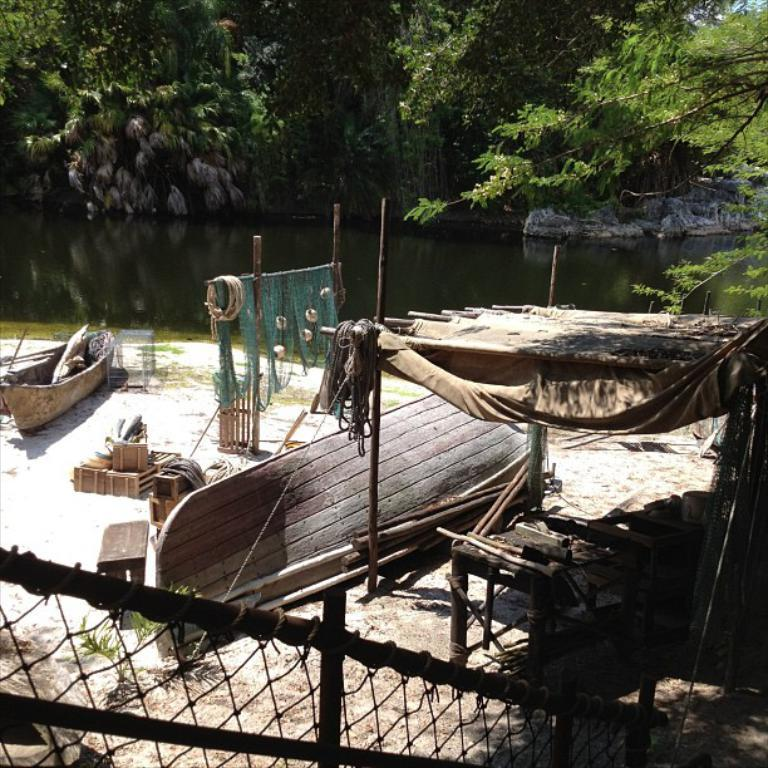What type of vehicles are present in the image? There are boats in the image. What are the boats using for fishing or other purposes? There are nets in the image. What can be seen in the background of the image? Water, rocks, and trees are visible in the background of the image. What type of spark can be seen coming from the boats in the image? There is no spark visible in the image; the boats are likely using motors or sails for propulsion. 